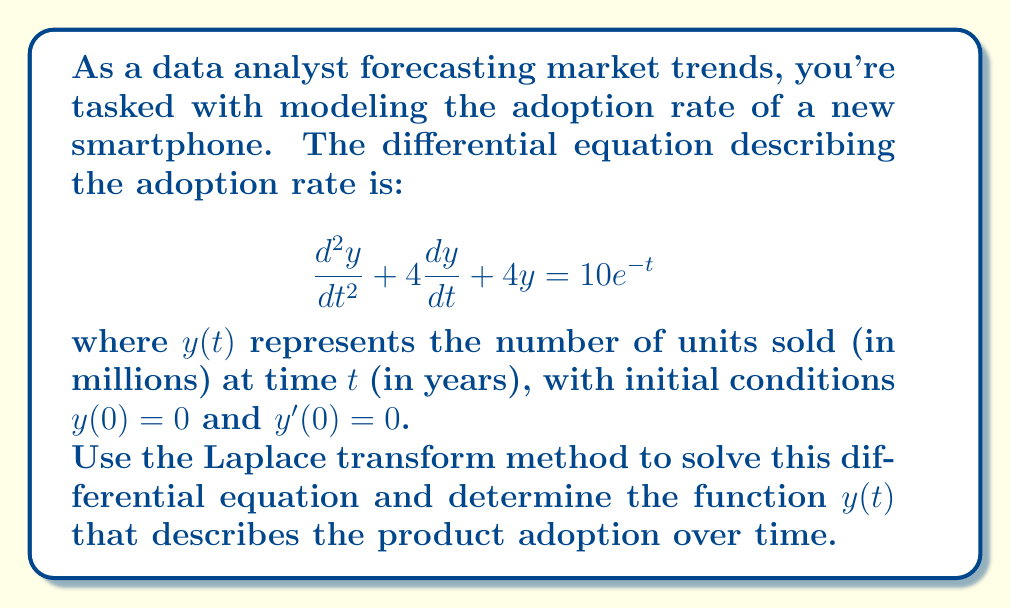Give your solution to this math problem. Let's solve this step-by-step using the Laplace transform method:

1) Take the Laplace transform of both sides of the equation:
   $$\mathcal{L}\{y''(t) + 4y'(t) + 4y(t)\} = \mathcal{L}\{10e^{-t}\}$$

2) Using Laplace transform properties:
   $$[s^2Y(s) - sy(0) - y'(0)] + 4[sY(s) - y(0)] + 4Y(s) = \frac{10}{s+1}$$

3) Substitute the initial conditions $y(0) = 0$ and $y'(0) = 0$:
   $$s^2Y(s) + 4sY(s) + 4Y(s) = \frac{10}{s+1}$$

4) Factor out $Y(s)$:
   $$Y(s)(s^2 + 4s + 4) = \frac{10}{s+1}$$

5) Simplify the left side:
   $$Y(s)(s + 2)^2 = \frac{10}{s+1}$$

6) Solve for $Y(s)$:
   $$Y(s) = \frac{10}{(s+1)(s+2)^2}$$

7) Decompose into partial fractions:
   $$Y(s) = \frac{A}{s+1} + \frac{B}{s+2} + \frac{C}{(s+2)^2}$$

8) Solve for $A$, $B$, and $C$:
   $A = 10$, $B = -20$, $C = 10$

9) Rewrite $Y(s)$:
   $$Y(s) = \frac{10}{s+1} - \frac{20}{s+2} + \frac{10}{(s+2)^2}$$

10) Take the inverse Laplace transform:
    $$y(t) = 10e^{-t} - 20e^{-2t} + 10te^{-2t}$$

This function $y(t)$ describes the number of units sold (in millions) over time $t$ (in years).
Answer: $y(t) = 10e^{-t} - 20e^{-2t} + 10te^{-2t}$ 